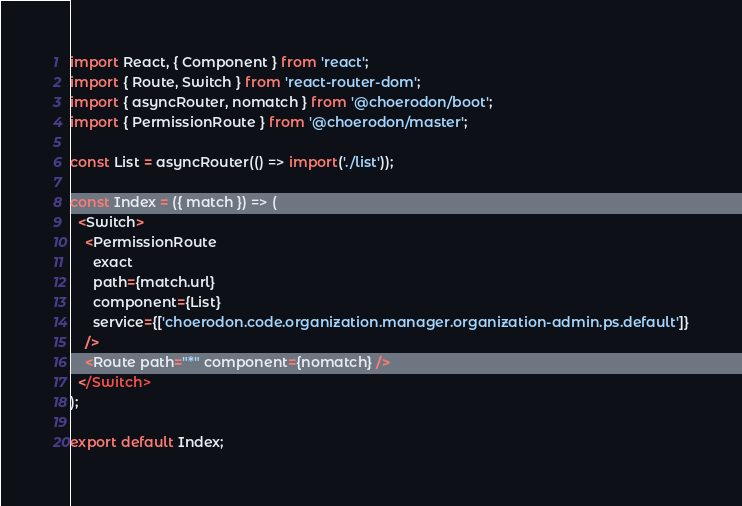<code> <loc_0><loc_0><loc_500><loc_500><_JavaScript_>import React, { Component } from 'react';
import { Route, Switch } from 'react-router-dom';
import { asyncRouter, nomatch } from '@choerodon/boot';
import { PermissionRoute } from '@choerodon/master';

const List = asyncRouter(() => import('./list'));

const Index = ({ match }) => (
  <Switch>
    <PermissionRoute
      exact
      path={match.url}
      component={List}
      service={['choerodon.code.organization.manager.organization-admin.ps.default']}
    />
    <Route path="*" component={nomatch} />
  </Switch>
);

export default Index;
</code> 